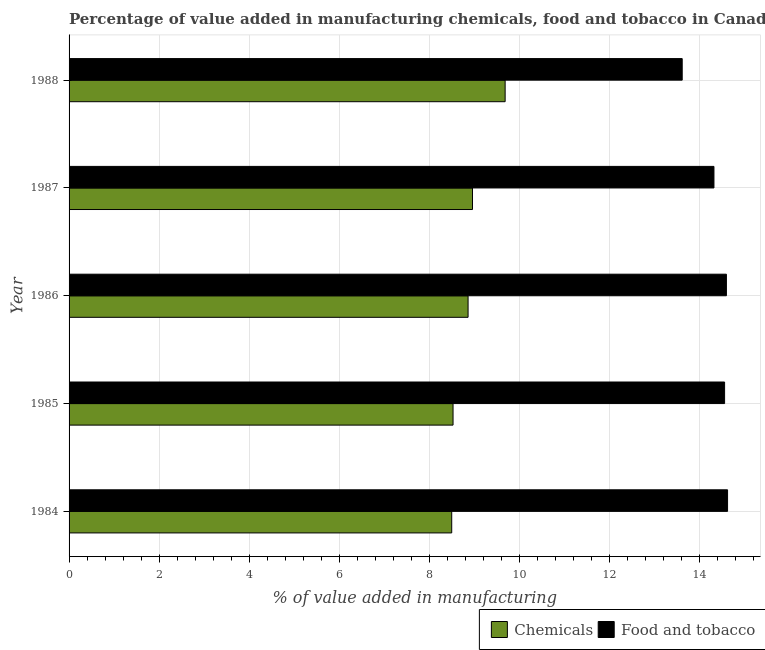Are the number of bars per tick equal to the number of legend labels?
Give a very brief answer. Yes. How many bars are there on the 1st tick from the top?
Give a very brief answer. 2. What is the value added by manufacturing food and tobacco in 1986?
Give a very brief answer. 14.59. Across all years, what is the maximum value added by  manufacturing chemicals?
Offer a terse response. 9.68. Across all years, what is the minimum value added by manufacturing food and tobacco?
Give a very brief answer. 13.61. In which year was the value added by manufacturing food and tobacco maximum?
Offer a terse response. 1984. What is the total value added by  manufacturing chemicals in the graph?
Give a very brief answer. 44.51. What is the difference between the value added by manufacturing food and tobacco in 1987 and that in 1988?
Your response must be concise. 0.7. What is the difference between the value added by manufacturing food and tobacco in 1988 and the value added by  manufacturing chemicals in 1986?
Your answer should be compact. 4.75. What is the average value added by  manufacturing chemicals per year?
Offer a terse response. 8.9. In the year 1987, what is the difference between the value added by  manufacturing chemicals and value added by manufacturing food and tobacco?
Your answer should be very brief. -5.36. In how many years, is the value added by manufacturing food and tobacco greater than 0.8 %?
Your answer should be compact. 5. What is the ratio of the value added by  manufacturing chemicals in 1984 to that in 1985?
Make the answer very short. 1. Is the difference between the value added by manufacturing food and tobacco in 1984 and 1988 greater than the difference between the value added by  manufacturing chemicals in 1984 and 1988?
Offer a terse response. Yes. What is the difference between the highest and the second highest value added by  manufacturing chemicals?
Ensure brevity in your answer.  0.72. What is the difference between the highest and the lowest value added by  manufacturing chemicals?
Offer a terse response. 1.19. In how many years, is the value added by manufacturing food and tobacco greater than the average value added by manufacturing food and tobacco taken over all years?
Keep it short and to the point. 3. What does the 1st bar from the top in 1987 represents?
Provide a succinct answer. Food and tobacco. What does the 1st bar from the bottom in 1987 represents?
Your response must be concise. Chemicals. How many bars are there?
Provide a succinct answer. 10. Are all the bars in the graph horizontal?
Provide a succinct answer. Yes. Are the values on the major ticks of X-axis written in scientific E-notation?
Ensure brevity in your answer.  No. Does the graph contain any zero values?
Ensure brevity in your answer.  No. Does the graph contain grids?
Your response must be concise. Yes. How many legend labels are there?
Your response must be concise. 2. What is the title of the graph?
Offer a terse response. Percentage of value added in manufacturing chemicals, food and tobacco in Canada. Does "Primary education" appear as one of the legend labels in the graph?
Offer a very short reply. No. What is the label or title of the X-axis?
Your answer should be very brief. % of value added in manufacturing. What is the % of value added in manufacturing of Chemicals in 1984?
Make the answer very short. 8.49. What is the % of value added in manufacturing of Food and tobacco in 1984?
Your answer should be very brief. 14.62. What is the % of value added in manufacturing in Chemicals in 1985?
Offer a terse response. 8.52. What is the % of value added in manufacturing of Food and tobacco in 1985?
Offer a terse response. 14.55. What is the % of value added in manufacturing of Chemicals in 1986?
Your response must be concise. 8.86. What is the % of value added in manufacturing in Food and tobacco in 1986?
Ensure brevity in your answer.  14.59. What is the % of value added in manufacturing of Chemicals in 1987?
Your answer should be compact. 8.96. What is the % of value added in manufacturing in Food and tobacco in 1987?
Keep it short and to the point. 14.31. What is the % of value added in manufacturing in Chemicals in 1988?
Offer a very short reply. 9.68. What is the % of value added in manufacturing in Food and tobacco in 1988?
Offer a terse response. 13.61. Across all years, what is the maximum % of value added in manufacturing of Chemicals?
Ensure brevity in your answer.  9.68. Across all years, what is the maximum % of value added in manufacturing of Food and tobacco?
Your answer should be compact. 14.62. Across all years, what is the minimum % of value added in manufacturing of Chemicals?
Your answer should be very brief. 8.49. Across all years, what is the minimum % of value added in manufacturing of Food and tobacco?
Your response must be concise. 13.61. What is the total % of value added in manufacturing of Chemicals in the graph?
Offer a very short reply. 44.51. What is the total % of value added in manufacturing of Food and tobacco in the graph?
Offer a very short reply. 71.68. What is the difference between the % of value added in manufacturing in Chemicals in 1984 and that in 1985?
Make the answer very short. -0.03. What is the difference between the % of value added in manufacturing of Food and tobacco in 1984 and that in 1985?
Your answer should be very brief. 0.07. What is the difference between the % of value added in manufacturing of Chemicals in 1984 and that in 1986?
Provide a short and direct response. -0.36. What is the difference between the % of value added in manufacturing of Food and tobacco in 1984 and that in 1986?
Offer a terse response. 0.03. What is the difference between the % of value added in manufacturing in Chemicals in 1984 and that in 1987?
Your answer should be compact. -0.46. What is the difference between the % of value added in manufacturing in Food and tobacco in 1984 and that in 1987?
Make the answer very short. 0.3. What is the difference between the % of value added in manufacturing of Chemicals in 1984 and that in 1988?
Provide a succinct answer. -1.19. What is the difference between the % of value added in manufacturing in Food and tobacco in 1984 and that in 1988?
Keep it short and to the point. 1.01. What is the difference between the % of value added in manufacturing in Chemicals in 1985 and that in 1986?
Provide a succinct answer. -0.33. What is the difference between the % of value added in manufacturing of Food and tobacco in 1985 and that in 1986?
Your response must be concise. -0.04. What is the difference between the % of value added in manufacturing in Chemicals in 1985 and that in 1987?
Ensure brevity in your answer.  -0.43. What is the difference between the % of value added in manufacturing of Food and tobacco in 1985 and that in 1987?
Ensure brevity in your answer.  0.24. What is the difference between the % of value added in manufacturing in Chemicals in 1985 and that in 1988?
Make the answer very short. -1.16. What is the difference between the % of value added in manufacturing of Food and tobacco in 1985 and that in 1988?
Your response must be concise. 0.94. What is the difference between the % of value added in manufacturing in Chemicals in 1986 and that in 1987?
Your answer should be very brief. -0.1. What is the difference between the % of value added in manufacturing in Food and tobacco in 1986 and that in 1987?
Offer a terse response. 0.28. What is the difference between the % of value added in manufacturing of Chemicals in 1986 and that in 1988?
Your answer should be very brief. -0.82. What is the difference between the % of value added in manufacturing of Food and tobacco in 1986 and that in 1988?
Provide a short and direct response. 0.98. What is the difference between the % of value added in manufacturing of Chemicals in 1987 and that in 1988?
Provide a succinct answer. -0.72. What is the difference between the % of value added in manufacturing of Food and tobacco in 1987 and that in 1988?
Provide a succinct answer. 0.7. What is the difference between the % of value added in manufacturing of Chemicals in 1984 and the % of value added in manufacturing of Food and tobacco in 1985?
Keep it short and to the point. -6.06. What is the difference between the % of value added in manufacturing in Chemicals in 1984 and the % of value added in manufacturing in Food and tobacco in 1986?
Provide a succinct answer. -6.1. What is the difference between the % of value added in manufacturing of Chemicals in 1984 and the % of value added in manufacturing of Food and tobacco in 1987?
Keep it short and to the point. -5.82. What is the difference between the % of value added in manufacturing of Chemicals in 1984 and the % of value added in manufacturing of Food and tobacco in 1988?
Your response must be concise. -5.12. What is the difference between the % of value added in manufacturing of Chemicals in 1985 and the % of value added in manufacturing of Food and tobacco in 1986?
Provide a succinct answer. -6.07. What is the difference between the % of value added in manufacturing of Chemicals in 1985 and the % of value added in manufacturing of Food and tobacco in 1987?
Offer a terse response. -5.79. What is the difference between the % of value added in manufacturing of Chemicals in 1985 and the % of value added in manufacturing of Food and tobacco in 1988?
Ensure brevity in your answer.  -5.09. What is the difference between the % of value added in manufacturing in Chemicals in 1986 and the % of value added in manufacturing in Food and tobacco in 1987?
Your answer should be compact. -5.46. What is the difference between the % of value added in manufacturing in Chemicals in 1986 and the % of value added in manufacturing in Food and tobacco in 1988?
Ensure brevity in your answer.  -4.75. What is the difference between the % of value added in manufacturing in Chemicals in 1987 and the % of value added in manufacturing in Food and tobacco in 1988?
Give a very brief answer. -4.65. What is the average % of value added in manufacturing in Chemicals per year?
Give a very brief answer. 8.9. What is the average % of value added in manufacturing in Food and tobacco per year?
Offer a terse response. 14.34. In the year 1984, what is the difference between the % of value added in manufacturing in Chemicals and % of value added in manufacturing in Food and tobacco?
Ensure brevity in your answer.  -6.12. In the year 1985, what is the difference between the % of value added in manufacturing of Chemicals and % of value added in manufacturing of Food and tobacco?
Ensure brevity in your answer.  -6.03. In the year 1986, what is the difference between the % of value added in manufacturing of Chemicals and % of value added in manufacturing of Food and tobacco?
Make the answer very short. -5.73. In the year 1987, what is the difference between the % of value added in manufacturing of Chemicals and % of value added in manufacturing of Food and tobacco?
Offer a terse response. -5.36. In the year 1988, what is the difference between the % of value added in manufacturing of Chemicals and % of value added in manufacturing of Food and tobacco?
Give a very brief answer. -3.93. What is the ratio of the % of value added in manufacturing of Chemicals in 1984 to that in 1985?
Give a very brief answer. 1. What is the ratio of the % of value added in manufacturing in Food and tobacco in 1984 to that in 1986?
Your answer should be compact. 1. What is the ratio of the % of value added in manufacturing of Chemicals in 1984 to that in 1987?
Offer a terse response. 0.95. What is the ratio of the % of value added in manufacturing of Food and tobacco in 1984 to that in 1987?
Give a very brief answer. 1.02. What is the ratio of the % of value added in manufacturing in Chemicals in 1984 to that in 1988?
Your response must be concise. 0.88. What is the ratio of the % of value added in manufacturing in Food and tobacco in 1984 to that in 1988?
Offer a terse response. 1.07. What is the ratio of the % of value added in manufacturing in Chemicals in 1985 to that in 1986?
Offer a very short reply. 0.96. What is the ratio of the % of value added in manufacturing in Food and tobacco in 1985 to that in 1986?
Your answer should be very brief. 1. What is the ratio of the % of value added in manufacturing of Chemicals in 1985 to that in 1987?
Provide a short and direct response. 0.95. What is the ratio of the % of value added in manufacturing in Food and tobacco in 1985 to that in 1987?
Offer a very short reply. 1.02. What is the ratio of the % of value added in manufacturing in Chemicals in 1985 to that in 1988?
Offer a very short reply. 0.88. What is the ratio of the % of value added in manufacturing of Food and tobacco in 1985 to that in 1988?
Make the answer very short. 1.07. What is the ratio of the % of value added in manufacturing in Chemicals in 1986 to that in 1987?
Your response must be concise. 0.99. What is the ratio of the % of value added in manufacturing of Food and tobacco in 1986 to that in 1987?
Offer a very short reply. 1.02. What is the ratio of the % of value added in manufacturing of Chemicals in 1986 to that in 1988?
Offer a terse response. 0.92. What is the ratio of the % of value added in manufacturing in Food and tobacco in 1986 to that in 1988?
Your answer should be compact. 1.07. What is the ratio of the % of value added in manufacturing in Chemicals in 1987 to that in 1988?
Provide a succinct answer. 0.93. What is the ratio of the % of value added in manufacturing of Food and tobacco in 1987 to that in 1988?
Give a very brief answer. 1.05. What is the difference between the highest and the second highest % of value added in manufacturing in Chemicals?
Make the answer very short. 0.72. What is the difference between the highest and the second highest % of value added in manufacturing in Food and tobacco?
Give a very brief answer. 0.03. What is the difference between the highest and the lowest % of value added in manufacturing of Chemicals?
Offer a terse response. 1.19. What is the difference between the highest and the lowest % of value added in manufacturing in Food and tobacco?
Make the answer very short. 1.01. 